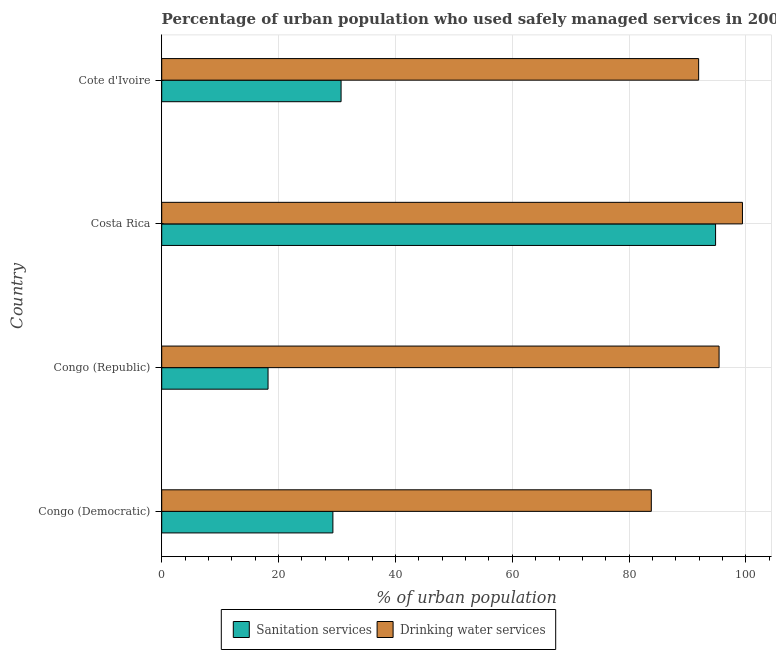What is the label of the 2nd group of bars from the top?
Your response must be concise. Costa Rica. In how many cases, is the number of bars for a given country not equal to the number of legend labels?
Your answer should be compact. 0. What is the percentage of urban population who used sanitation services in Congo (Democratic)?
Your response must be concise. 29.3. Across all countries, what is the maximum percentage of urban population who used drinking water services?
Keep it short and to the point. 99.4. Across all countries, what is the minimum percentage of urban population who used sanitation services?
Offer a terse response. 18.2. In which country was the percentage of urban population who used sanitation services maximum?
Offer a terse response. Costa Rica. In which country was the percentage of urban population who used drinking water services minimum?
Offer a terse response. Congo (Democratic). What is the total percentage of urban population who used sanitation services in the graph?
Make the answer very short. 173. What is the difference between the percentage of urban population who used sanitation services in Congo (Democratic) and that in Costa Rica?
Your answer should be compact. -65.5. What is the difference between the percentage of urban population who used drinking water services in Congo (Democratic) and the percentage of urban population who used sanitation services in Congo (Republic)?
Provide a short and direct response. 65.6. What is the average percentage of urban population who used sanitation services per country?
Keep it short and to the point. 43.25. What is the difference between the percentage of urban population who used sanitation services and percentage of urban population who used drinking water services in Cote d'Ivoire?
Your answer should be very brief. -61.2. In how many countries, is the percentage of urban population who used sanitation services greater than 28 %?
Offer a terse response. 3. Is the percentage of urban population who used drinking water services in Congo (Democratic) less than that in Congo (Republic)?
Your answer should be very brief. Yes. Is the difference between the percentage of urban population who used sanitation services in Congo (Republic) and Costa Rica greater than the difference between the percentage of urban population who used drinking water services in Congo (Republic) and Costa Rica?
Provide a succinct answer. No. What is the difference between the highest and the lowest percentage of urban population who used sanitation services?
Your answer should be very brief. 76.6. In how many countries, is the percentage of urban population who used sanitation services greater than the average percentage of urban population who used sanitation services taken over all countries?
Your answer should be very brief. 1. What does the 1st bar from the top in Cote d'Ivoire represents?
Make the answer very short. Drinking water services. What does the 2nd bar from the bottom in Congo (Democratic) represents?
Provide a short and direct response. Drinking water services. How many bars are there?
Your answer should be compact. 8. Are all the bars in the graph horizontal?
Offer a terse response. Yes. How many countries are there in the graph?
Make the answer very short. 4. What is the difference between two consecutive major ticks on the X-axis?
Your answer should be very brief. 20. Are the values on the major ticks of X-axis written in scientific E-notation?
Ensure brevity in your answer.  No. Does the graph contain grids?
Provide a short and direct response. Yes. How are the legend labels stacked?
Give a very brief answer. Horizontal. What is the title of the graph?
Ensure brevity in your answer.  Percentage of urban population who used safely managed services in 2004. What is the label or title of the X-axis?
Provide a short and direct response. % of urban population. What is the label or title of the Y-axis?
Offer a very short reply. Country. What is the % of urban population in Sanitation services in Congo (Democratic)?
Your answer should be very brief. 29.3. What is the % of urban population of Drinking water services in Congo (Democratic)?
Keep it short and to the point. 83.8. What is the % of urban population in Sanitation services in Congo (Republic)?
Give a very brief answer. 18.2. What is the % of urban population of Drinking water services in Congo (Republic)?
Provide a succinct answer. 95.4. What is the % of urban population of Sanitation services in Costa Rica?
Keep it short and to the point. 94.8. What is the % of urban population of Drinking water services in Costa Rica?
Your answer should be very brief. 99.4. What is the % of urban population of Sanitation services in Cote d'Ivoire?
Your answer should be very brief. 30.7. What is the % of urban population of Drinking water services in Cote d'Ivoire?
Provide a succinct answer. 91.9. Across all countries, what is the maximum % of urban population in Sanitation services?
Your response must be concise. 94.8. Across all countries, what is the maximum % of urban population of Drinking water services?
Your answer should be very brief. 99.4. Across all countries, what is the minimum % of urban population in Sanitation services?
Your response must be concise. 18.2. Across all countries, what is the minimum % of urban population of Drinking water services?
Give a very brief answer. 83.8. What is the total % of urban population in Sanitation services in the graph?
Offer a terse response. 173. What is the total % of urban population of Drinking water services in the graph?
Provide a short and direct response. 370.5. What is the difference between the % of urban population in Sanitation services in Congo (Democratic) and that in Costa Rica?
Give a very brief answer. -65.5. What is the difference between the % of urban population of Drinking water services in Congo (Democratic) and that in Costa Rica?
Keep it short and to the point. -15.6. What is the difference between the % of urban population of Sanitation services in Congo (Republic) and that in Costa Rica?
Make the answer very short. -76.6. What is the difference between the % of urban population of Drinking water services in Congo (Republic) and that in Cote d'Ivoire?
Make the answer very short. 3.5. What is the difference between the % of urban population of Sanitation services in Costa Rica and that in Cote d'Ivoire?
Provide a short and direct response. 64.1. What is the difference between the % of urban population of Drinking water services in Costa Rica and that in Cote d'Ivoire?
Your response must be concise. 7.5. What is the difference between the % of urban population of Sanitation services in Congo (Democratic) and the % of urban population of Drinking water services in Congo (Republic)?
Ensure brevity in your answer.  -66.1. What is the difference between the % of urban population of Sanitation services in Congo (Democratic) and the % of urban population of Drinking water services in Costa Rica?
Keep it short and to the point. -70.1. What is the difference between the % of urban population in Sanitation services in Congo (Democratic) and the % of urban population in Drinking water services in Cote d'Ivoire?
Provide a short and direct response. -62.6. What is the difference between the % of urban population in Sanitation services in Congo (Republic) and the % of urban population in Drinking water services in Costa Rica?
Provide a short and direct response. -81.2. What is the difference between the % of urban population of Sanitation services in Congo (Republic) and the % of urban population of Drinking water services in Cote d'Ivoire?
Your answer should be compact. -73.7. What is the average % of urban population in Sanitation services per country?
Your answer should be very brief. 43.25. What is the average % of urban population in Drinking water services per country?
Offer a very short reply. 92.62. What is the difference between the % of urban population of Sanitation services and % of urban population of Drinking water services in Congo (Democratic)?
Make the answer very short. -54.5. What is the difference between the % of urban population in Sanitation services and % of urban population in Drinking water services in Congo (Republic)?
Ensure brevity in your answer.  -77.2. What is the difference between the % of urban population in Sanitation services and % of urban population in Drinking water services in Cote d'Ivoire?
Make the answer very short. -61.2. What is the ratio of the % of urban population in Sanitation services in Congo (Democratic) to that in Congo (Republic)?
Offer a very short reply. 1.61. What is the ratio of the % of urban population of Drinking water services in Congo (Democratic) to that in Congo (Republic)?
Provide a short and direct response. 0.88. What is the ratio of the % of urban population of Sanitation services in Congo (Democratic) to that in Costa Rica?
Your answer should be very brief. 0.31. What is the ratio of the % of urban population in Drinking water services in Congo (Democratic) to that in Costa Rica?
Provide a succinct answer. 0.84. What is the ratio of the % of urban population in Sanitation services in Congo (Democratic) to that in Cote d'Ivoire?
Your answer should be compact. 0.95. What is the ratio of the % of urban population in Drinking water services in Congo (Democratic) to that in Cote d'Ivoire?
Your answer should be compact. 0.91. What is the ratio of the % of urban population in Sanitation services in Congo (Republic) to that in Costa Rica?
Your response must be concise. 0.19. What is the ratio of the % of urban population of Drinking water services in Congo (Republic) to that in Costa Rica?
Offer a very short reply. 0.96. What is the ratio of the % of urban population in Sanitation services in Congo (Republic) to that in Cote d'Ivoire?
Offer a very short reply. 0.59. What is the ratio of the % of urban population of Drinking water services in Congo (Republic) to that in Cote d'Ivoire?
Your answer should be compact. 1.04. What is the ratio of the % of urban population of Sanitation services in Costa Rica to that in Cote d'Ivoire?
Provide a short and direct response. 3.09. What is the ratio of the % of urban population in Drinking water services in Costa Rica to that in Cote d'Ivoire?
Your answer should be compact. 1.08. What is the difference between the highest and the second highest % of urban population in Sanitation services?
Provide a succinct answer. 64.1. What is the difference between the highest and the second highest % of urban population of Drinking water services?
Keep it short and to the point. 4. What is the difference between the highest and the lowest % of urban population in Sanitation services?
Offer a terse response. 76.6. 